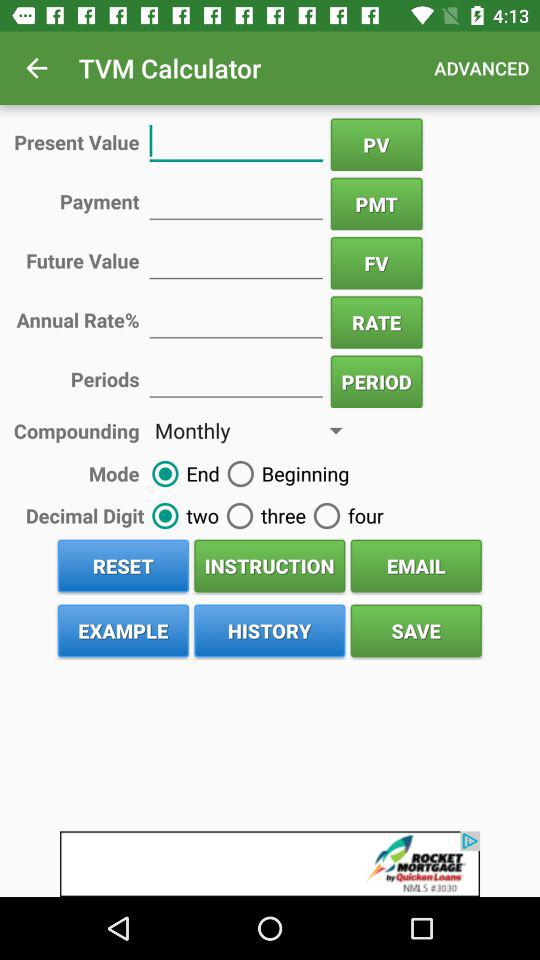Which mode is selected? The selected mode is "End". 